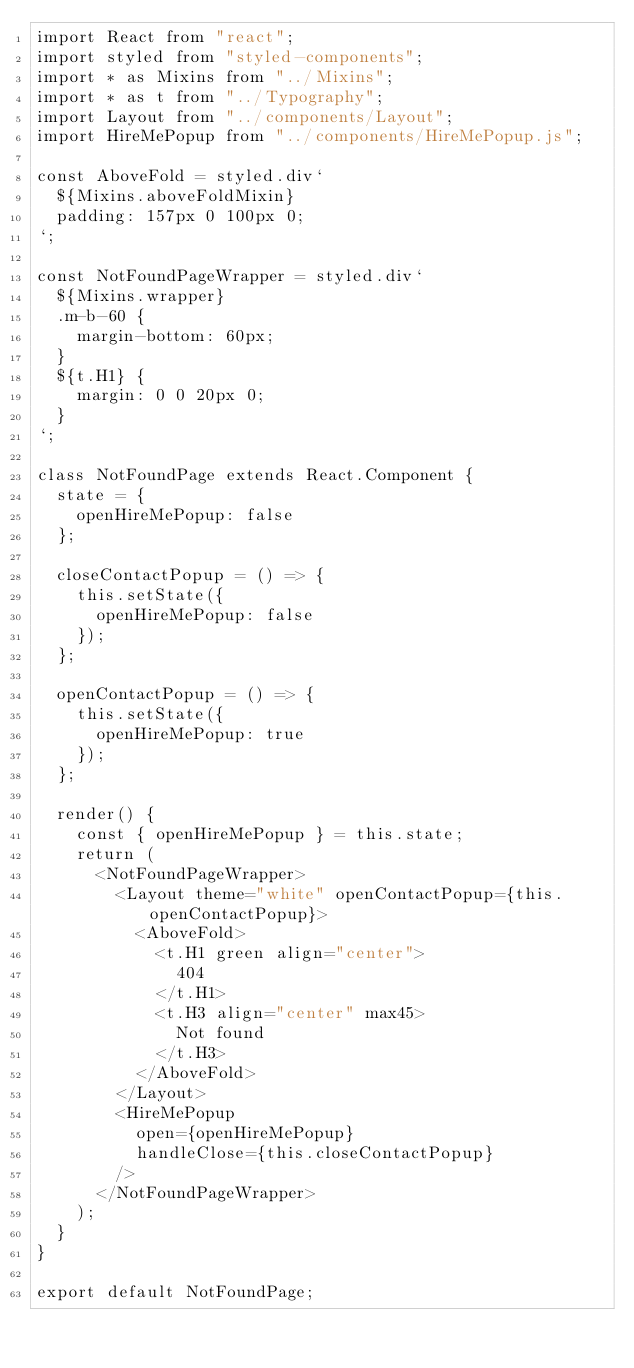Convert code to text. <code><loc_0><loc_0><loc_500><loc_500><_JavaScript_>import React from "react";
import styled from "styled-components";
import * as Mixins from "../Mixins";
import * as t from "../Typography";
import Layout from "../components/Layout";
import HireMePopup from "../components/HireMePopup.js";

const AboveFold = styled.div`
  ${Mixins.aboveFoldMixin}
  padding: 157px 0 100px 0;
`;

const NotFoundPageWrapper = styled.div`
  ${Mixins.wrapper}
  .m-b-60 {
    margin-bottom: 60px;
  }
  ${t.H1} {
    margin: 0 0 20px 0;
  }
`;

class NotFoundPage extends React.Component {
  state = {
    openHireMePopup: false
  };

  closeContactPopup = () => {
    this.setState({
      openHireMePopup: false
    });
  };

  openContactPopup = () => {
    this.setState({
      openHireMePopup: true
    });
  };

  render() {
    const { openHireMePopup } = this.state;
    return (
      <NotFoundPageWrapper>
        <Layout theme="white" openContactPopup={this.openContactPopup}>
          <AboveFold>
            <t.H1 green align="center">
              404
            </t.H1>
            <t.H3 align="center" max45>
              Not found
            </t.H3>
          </AboveFold>
        </Layout>
        <HireMePopup
          open={openHireMePopup}
          handleClose={this.closeContactPopup}
        />
      </NotFoundPageWrapper>
    );
  }
}

export default NotFoundPage;
</code> 